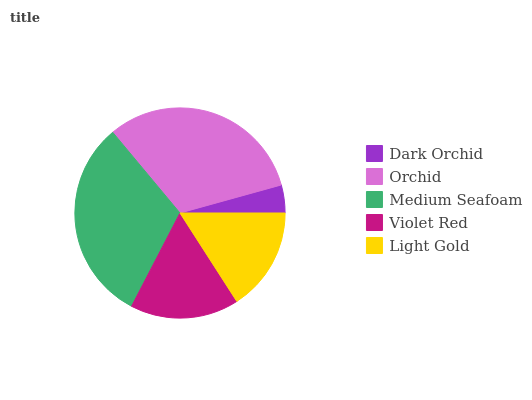Is Dark Orchid the minimum?
Answer yes or no. Yes. Is Orchid the maximum?
Answer yes or no. Yes. Is Medium Seafoam the minimum?
Answer yes or no. No. Is Medium Seafoam the maximum?
Answer yes or no. No. Is Orchid greater than Medium Seafoam?
Answer yes or no. Yes. Is Medium Seafoam less than Orchid?
Answer yes or no. Yes. Is Medium Seafoam greater than Orchid?
Answer yes or no. No. Is Orchid less than Medium Seafoam?
Answer yes or no. No. Is Violet Red the high median?
Answer yes or no. Yes. Is Violet Red the low median?
Answer yes or no. Yes. Is Medium Seafoam the high median?
Answer yes or no. No. Is Orchid the low median?
Answer yes or no. No. 